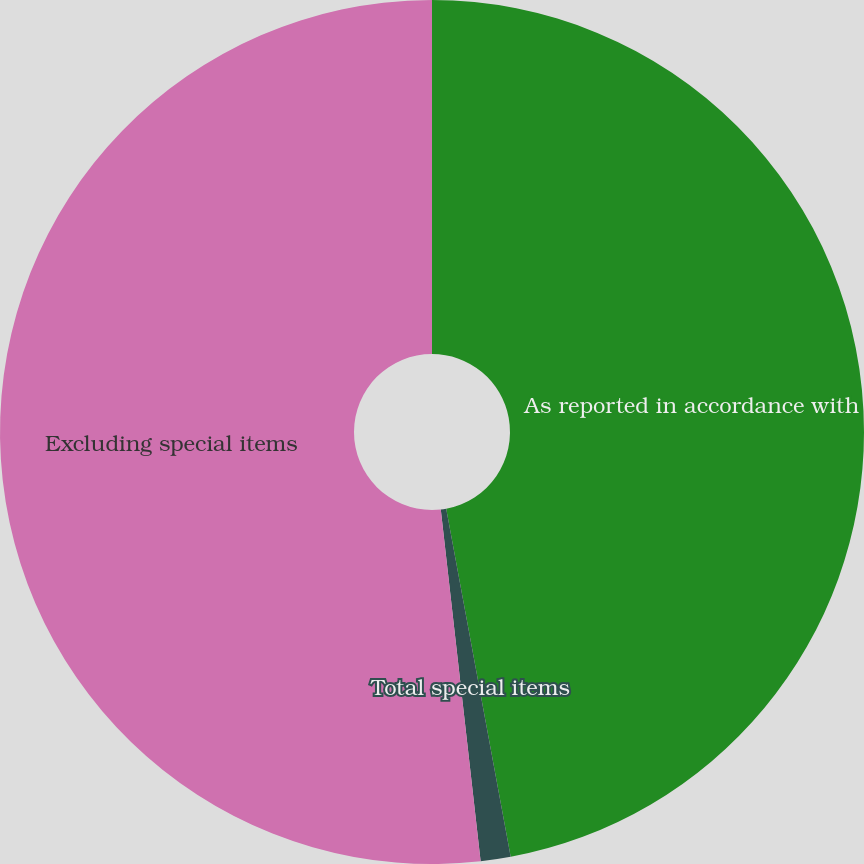<chart> <loc_0><loc_0><loc_500><loc_500><pie_chart><fcel>As reported in accordance with<fcel>Total special items<fcel>Excluding special items<nl><fcel>47.08%<fcel>1.12%<fcel>51.79%<nl></chart> 